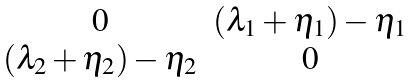Convert formula to latex. <formula><loc_0><loc_0><loc_500><loc_500>\begin{matrix} 0 & ( \lambda _ { 1 } + \eta _ { 1 } ) - \eta _ { 1 } \\ ( \lambda _ { 2 } + \eta _ { 2 } ) - \eta _ { 2 } & 0 \end{matrix}</formula> 